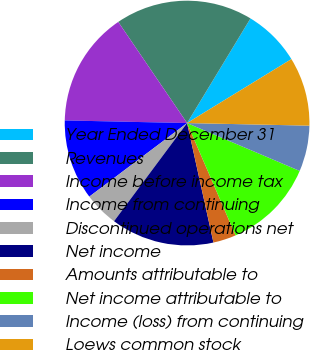Convert chart. <chart><loc_0><loc_0><loc_500><loc_500><pie_chart><fcel>Year Ended December 31<fcel>Revenues<fcel>Income before income tax<fcel>Income from continuing<fcel>Discontinued operations net<fcel>Net income<fcel>Amounts attributable to<fcel>Net income attributable to<fcel>Income (loss) from continuing<fcel>Loews common stock<nl><fcel>7.58%<fcel>18.18%<fcel>15.15%<fcel>10.61%<fcel>4.55%<fcel>13.64%<fcel>3.03%<fcel>12.12%<fcel>6.06%<fcel>9.09%<nl></chart> 